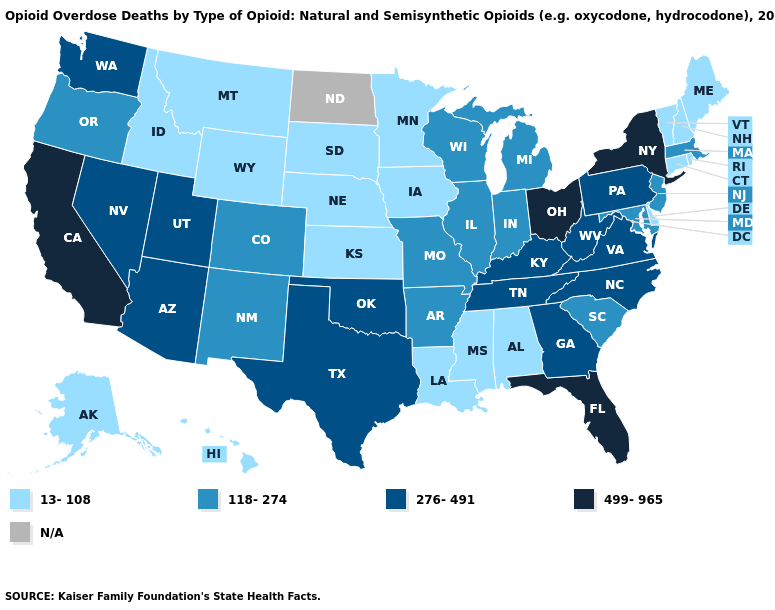Name the states that have a value in the range 13-108?
Quick response, please. Alabama, Alaska, Connecticut, Delaware, Hawaii, Idaho, Iowa, Kansas, Louisiana, Maine, Minnesota, Mississippi, Montana, Nebraska, New Hampshire, Rhode Island, South Dakota, Vermont, Wyoming. Does South Dakota have the lowest value in the MidWest?
Quick response, please. Yes. Which states have the highest value in the USA?
Answer briefly. California, Florida, New York, Ohio. What is the value of Oregon?
Write a very short answer. 118-274. What is the highest value in the West ?
Concise answer only. 499-965. Name the states that have a value in the range 499-965?
Concise answer only. California, Florida, New York, Ohio. Which states have the lowest value in the USA?
Be succinct. Alabama, Alaska, Connecticut, Delaware, Hawaii, Idaho, Iowa, Kansas, Louisiana, Maine, Minnesota, Mississippi, Montana, Nebraska, New Hampshire, Rhode Island, South Dakota, Vermont, Wyoming. What is the value of Massachusetts?
Answer briefly. 118-274. What is the lowest value in states that border Connecticut?
Write a very short answer. 13-108. What is the value of Wisconsin?
Concise answer only. 118-274. What is the value of Washington?
Be succinct. 276-491. Does the map have missing data?
Give a very brief answer. Yes. What is the highest value in the Northeast ?
Be succinct. 499-965. What is the highest value in states that border Iowa?
Answer briefly. 118-274. 